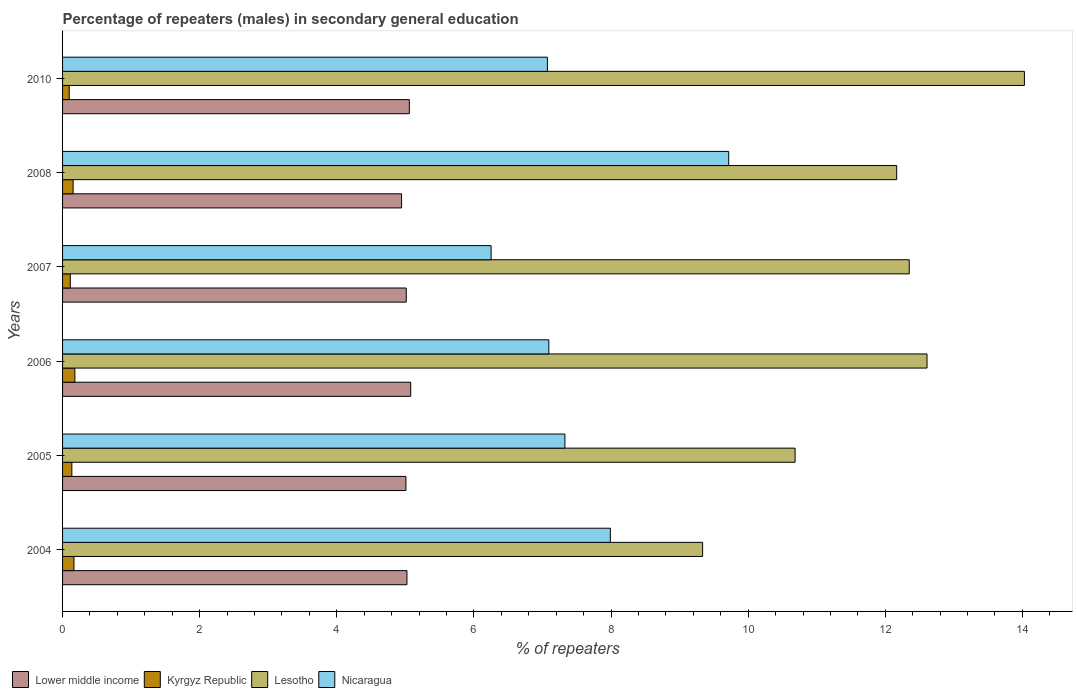How many different coloured bars are there?
Ensure brevity in your answer.  4. How many bars are there on the 2nd tick from the top?
Make the answer very short. 4. How many bars are there on the 3rd tick from the bottom?
Give a very brief answer. 4. What is the label of the 1st group of bars from the top?
Offer a very short reply. 2010. What is the percentage of male repeaters in Lesotho in 2005?
Keep it short and to the point. 10.68. Across all years, what is the maximum percentage of male repeaters in Lesotho?
Keep it short and to the point. 14.03. Across all years, what is the minimum percentage of male repeaters in Lower middle income?
Offer a very short reply. 4.94. What is the total percentage of male repeaters in Kyrgyz Republic in the graph?
Give a very brief answer. 0.84. What is the difference between the percentage of male repeaters in Nicaragua in 2006 and that in 2007?
Your answer should be compact. 0.84. What is the difference between the percentage of male repeaters in Lesotho in 2006 and the percentage of male repeaters in Lower middle income in 2008?
Provide a succinct answer. 7.66. What is the average percentage of male repeaters in Kyrgyz Republic per year?
Your answer should be very brief. 0.14. In the year 2007, what is the difference between the percentage of male repeaters in Kyrgyz Republic and percentage of male repeaters in Lower middle income?
Offer a terse response. -4.9. What is the ratio of the percentage of male repeaters in Lesotho in 2004 to that in 2005?
Offer a very short reply. 0.87. Is the difference between the percentage of male repeaters in Kyrgyz Republic in 2005 and 2008 greater than the difference between the percentage of male repeaters in Lower middle income in 2005 and 2008?
Give a very brief answer. No. What is the difference between the highest and the second highest percentage of male repeaters in Kyrgyz Republic?
Offer a terse response. 0.01. What is the difference between the highest and the lowest percentage of male repeaters in Lower middle income?
Your answer should be very brief. 0.13. What does the 2nd bar from the top in 2006 represents?
Make the answer very short. Lesotho. What does the 4th bar from the bottom in 2004 represents?
Give a very brief answer. Nicaragua. Is it the case that in every year, the sum of the percentage of male repeaters in Nicaragua and percentage of male repeaters in Kyrgyz Republic is greater than the percentage of male repeaters in Lesotho?
Your response must be concise. No. Are the values on the major ticks of X-axis written in scientific E-notation?
Offer a very short reply. No. Does the graph contain grids?
Offer a very short reply. No. Where does the legend appear in the graph?
Provide a succinct answer. Bottom left. How many legend labels are there?
Ensure brevity in your answer.  4. How are the legend labels stacked?
Provide a succinct answer. Horizontal. What is the title of the graph?
Make the answer very short. Percentage of repeaters (males) in secondary general education. Does "Tonga" appear as one of the legend labels in the graph?
Give a very brief answer. No. What is the label or title of the X-axis?
Provide a short and direct response. % of repeaters. What is the label or title of the Y-axis?
Offer a terse response. Years. What is the % of repeaters in Lower middle income in 2004?
Provide a short and direct response. 5.02. What is the % of repeaters in Kyrgyz Republic in 2004?
Give a very brief answer. 0.17. What is the % of repeaters of Lesotho in 2004?
Your answer should be very brief. 9.34. What is the % of repeaters of Nicaragua in 2004?
Make the answer very short. 7.99. What is the % of repeaters in Lower middle income in 2005?
Your answer should be very brief. 5.01. What is the % of repeaters of Kyrgyz Republic in 2005?
Your answer should be compact. 0.14. What is the % of repeaters of Lesotho in 2005?
Offer a very short reply. 10.68. What is the % of repeaters of Nicaragua in 2005?
Ensure brevity in your answer.  7.33. What is the % of repeaters in Lower middle income in 2006?
Provide a short and direct response. 5.08. What is the % of repeaters in Kyrgyz Republic in 2006?
Your response must be concise. 0.18. What is the % of repeaters in Lesotho in 2006?
Make the answer very short. 12.61. What is the % of repeaters of Nicaragua in 2006?
Provide a short and direct response. 7.09. What is the % of repeaters of Lower middle income in 2007?
Give a very brief answer. 5.01. What is the % of repeaters in Kyrgyz Republic in 2007?
Keep it short and to the point. 0.11. What is the % of repeaters in Lesotho in 2007?
Your answer should be very brief. 12.35. What is the % of repeaters of Nicaragua in 2007?
Give a very brief answer. 6.25. What is the % of repeaters of Lower middle income in 2008?
Give a very brief answer. 4.94. What is the % of repeaters in Kyrgyz Republic in 2008?
Your answer should be compact. 0.15. What is the % of repeaters of Lesotho in 2008?
Your answer should be compact. 12.17. What is the % of repeaters in Nicaragua in 2008?
Keep it short and to the point. 9.72. What is the % of repeaters in Lower middle income in 2010?
Give a very brief answer. 5.06. What is the % of repeaters of Kyrgyz Republic in 2010?
Your answer should be compact. 0.1. What is the % of repeaters of Lesotho in 2010?
Your answer should be compact. 14.03. What is the % of repeaters in Nicaragua in 2010?
Make the answer very short. 7.07. Across all years, what is the maximum % of repeaters in Lower middle income?
Ensure brevity in your answer.  5.08. Across all years, what is the maximum % of repeaters of Kyrgyz Republic?
Keep it short and to the point. 0.18. Across all years, what is the maximum % of repeaters in Lesotho?
Ensure brevity in your answer.  14.03. Across all years, what is the maximum % of repeaters in Nicaragua?
Ensure brevity in your answer.  9.72. Across all years, what is the minimum % of repeaters in Lower middle income?
Offer a terse response. 4.94. Across all years, what is the minimum % of repeaters of Kyrgyz Republic?
Your answer should be compact. 0.1. Across all years, what is the minimum % of repeaters of Lesotho?
Your response must be concise. 9.34. Across all years, what is the minimum % of repeaters in Nicaragua?
Provide a succinct answer. 6.25. What is the total % of repeaters in Lower middle income in the graph?
Ensure brevity in your answer.  30.13. What is the total % of repeaters of Kyrgyz Republic in the graph?
Give a very brief answer. 0.84. What is the total % of repeaters in Lesotho in the graph?
Give a very brief answer. 71.18. What is the total % of repeaters in Nicaragua in the graph?
Keep it short and to the point. 45.45. What is the difference between the % of repeaters of Lower middle income in 2004 and that in 2005?
Your answer should be compact. 0.01. What is the difference between the % of repeaters of Kyrgyz Republic in 2004 and that in 2005?
Your answer should be very brief. 0.03. What is the difference between the % of repeaters of Lesotho in 2004 and that in 2005?
Your response must be concise. -1.35. What is the difference between the % of repeaters of Nicaragua in 2004 and that in 2005?
Make the answer very short. 0.66. What is the difference between the % of repeaters in Lower middle income in 2004 and that in 2006?
Offer a terse response. -0.05. What is the difference between the % of repeaters in Kyrgyz Republic in 2004 and that in 2006?
Provide a short and direct response. -0.01. What is the difference between the % of repeaters in Lesotho in 2004 and that in 2006?
Provide a succinct answer. -3.27. What is the difference between the % of repeaters of Nicaragua in 2004 and that in 2006?
Offer a very short reply. 0.9. What is the difference between the % of repeaters in Lower middle income in 2004 and that in 2007?
Provide a short and direct response. 0.01. What is the difference between the % of repeaters of Kyrgyz Republic in 2004 and that in 2007?
Make the answer very short. 0.05. What is the difference between the % of repeaters of Lesotho in 2004 and that in 2007?
Offer a terse response. -3.01. What is the difference between the % of repeaters of Nicaragua in 2004 and that in 2007?
Make the answer very short. 1.74. What is the difference between the % of repeaters of Lower middle income in 2004 and that in 2008?
Ensure brevity in your answer.  0.08. What is the difference between the % of repeaters in Kyrgyz Republic in 2004 and that in 2008?
Provide a short and direct response. 0.01. What is the difference between the % of repeaters of Lesotho in 2004 and that in 2008?
Provide a succinct answer. -2.83. What is the difference between the % of repeaters of Nicaragua in 2004 and that in 2008?
Ensure brevity in your answer.  -1.73. What is the difference between the % of repeaters of Lower middle income in 2004 and that in 2010?
Give a very brief answer. -0.03. What is the difference between the % of repeaters in Kyrgyz Republic in 2004 and that in 2010?
Ensure brevity in your answer.  0.07. What is the difference between the % of repeaters of Lesotho in 2004 and that in 2010?
Your answer should be very brief. -4.69. What is the difference between the % of repeaters of Nicaragua in 2004 and that in 2010?
Give a very brief answer. 0.92. What is the difference between the % of repeaters in Lower middle income in 2005 and that in 2006?
Provide a succinct answer. -0.07. What is the difference between the % of repeaters in Kyrgyz Republic in 2005 and that in 2006?
Give a very brief answer. -0.04. What is the difference between the % of repeaters of Lesotho in 2005 and that in 2006?
Make the answer very short. -1.92. What is the difference between the % of repeaters of Nicaragua in 2005 and that in 2006?
Provide a succinct answer. 0.23. What is the difference between the % of repeaters of Lower middle income in 2005 and that in 2007?
Offer a terse response. -0. What is the difference between the % of repeaters in Kyrgyz Republic in 2005 and that in 2007?
Make the answer very short. 0.02. What is the difference between the % of repeaters in Lesotho in 2005 and that in 2007?
Offer a terse response. -1.66. What is the difference between the % of repeaters of Nicaragua in 2005 and that in 2007?
Make the answer very short. 1.08. What is the difference between the % of repeaters of Lower middle income in 2005 and that in 2008?
Your answer should be very brief. 0.06. What is the difference between the % of repeaters in Kyrgyz Republic in 2005 and that in 2008?
Give a very brief answer. -0.02. What is the difference between the % of repeaters of Lesotho in 2005 and that in 2008?
Make the answer very short. -1.48. What is the difference between the % of repeaters in Nicaragua in 2005 and that in 2008?
Provide a succinct answer. -2.39. What is the difference between the % of repeaters of Lower middle income in 2005 and that in 2010?
Your answer should be compact. -0.05. What is the difference between the % of repeaters in Kyrgyz Republic in 2005 and that in 2010?
Provide a short and direct response. 0.04. What is the difference between the % of repeaters in Lesotho in 2005 and that in 2010?
Offer a terse response. -3.34. What is the difference between the % of repeaters of Nicaragua in 2005 and that in 2010?
Make the answer very short. 0.26. What is the difference between the % of repeaters of Lower middle income in 2006 and that in 2007?
Provide a succinct answer. 0.06. What is the difference between the % of repeaters of Kyrgyz Republic in 2006 and that in 2007?
Keep it short and to the point. 0.07. What is the difference between the % of repeaters of Lesotho in 2006 and that in 2007?
Your answer should be very brief. 0.26. What is the difference between the % of repeaters in Nicaragua in 2006 and that in 2007?
Ensure brevity in your answer.  0.84. What is the difference between the % of repeaters of Lower middle income in 2006 and that in 2008?
Your answer should be very brief. 0.13. What is the difference between the % of repeaters in Kyrgyz Republic in 2006 and that in 2008?
Provide a short and direct response. 0.03. What is the difference between the % of repeaters in Lesotho in 2006 and that in 2008?
Offer a very short reply. 0.44. What is the difference between the % of repeaters of Nicaragua in 2006 and that in 2008?
Your answer should be compact. -2.62. What is the difference between the % of repeaters in Lower middle income in 2006 and that in 2010?
Ensure brevity in your answer.  0.02. What is the difference between the % of repeaters of Kyrgyz Republic in 2006 and that in 2010?
Provide a succinct answer. 0.08. What is the difference between the % of repeaters of Lesotho in 2006 and that in 2010?
Give a very brief answer. -1.42. What is the difference between the % of repeaters in Nicaragua in 2006 and that in 2010?
Ensure brevity in your answer.  0.02. What is the difference between the % of repeaters in Lower middle income in 2007 and that in 2008?
Offer a very short reply. 0.07. What is the difference between the % of repeaters of Kyrgyz Republic in 2007 and that in 2008?
Your answer should be compact. -0.04. What is the difference between the % of repeaters in Lesotho in 2007 and that in 2008?
Keep it short and to the point. 0.18. What is the difference between the % of repeaters in Nicaragua in 2007 and that in 2008?
Provide a short and direct response. -3.47. What is the difference between the % of repeaters of Lower middle income in 2007 and that in 2010?
Ensure brevity in your answer.  -0.04. What is the difference between the % of repeaters of Kyrgyz Republic in 2007 and that in 2010?
Provide a succinct answer. 0.02. What is the difference between the % of repeaters of Lesotho in 2007 and that in 2010?
Your answer should be very brief. -1.68. What is the difference between the % of repeaters in Nicaragua in 2007 and that in 2010?
Offer a very short reply. -0.82. What is the difference between the % of repeaters of Lower middle income in 2008 and that in 2010?
Your answer should be very brief. -0.11. What is the difference between the % of repeaters in Kyrgyz Republic in 2008 and that in 2010?
Give a very brief answer. 0.06. What is the difference between the % of repeaters in Lesotho in 2008 and that in 2010?
Provide a succinct answer. -1.86. What is the difference between the % of repeaters in Nicaragua in 2008 and that in 2010?
Keep it short and to the point. 2.64. What is the difference between the % of repeaters of Lower middle income in 2004 and the % of repeaters of Kyrgyz Republic in 2005?
Give a very brief answer. 4.89. What is the difference between the % of repeaters of Lower middle income in 2004 and the % of repeaters of Lesotho in 2005?
Your answer should be very brief. -5.66. What is the difference between the % of repeaters of Lower middle income in 2004 and the % of repeaters of Nicaragua in 2005?
Offer a terse response. -2.3. What is the difference between the % of repeaters in Kyrgyz Republic in 2004 and the % of repeaters in Lesotho in 2005?
Your answer should be compact. -10.52. What is the difference between the % of repeaters of Kyrgyz Republic in 2004 and the % of repeaters of Nicaragua in 2005?
Your answer should be compact. -7.16. What is the difference between the % of repeaters of Lesotho in 2004 and the % of repeaters of Nicaragua in 2005?
Give a very brief answer. 2.01. What is the difference between the % of repeaters in Lower middle income in 2004 and the % of repeaters in Kyrgyz Republic in 2006?
Keep it short and to the point. 4.84. What is the difference between the % of repeaters in Lower middle income in 2004 and the % of repeaters in Lesotho in 2006?
Provide a succinct answer. -7.59. What is the difference between the % of repeaters in Lower middle income in 2004 and the % of repeaters in Nicaragua in 2006?
Provide a short and direct response. -2.07. What is the difference between the % of repeaters of Kyrgyz Republic in 2004 and the % of repeaters of Lesotho in 2006?
Ensure brevity in your answer.  -12.44. What is the difference between the % of repeaters of Kyrgyz Republic in 2004 and the % of repeaters of Nicaragua in 2006?
Keep it short and to the point. -6.93. What is the difference between the % of repeaters in Lesotho in 2004 and the % of repeaters in Nicaragua in 2006?
Offer a terse response. 2.24. What is the difference between the % of repeaters in Lower middle income in 2004 and the % of repeaters in Kyrgyz Republic in 2007?
Your response must be concise. 4.91. What is the difference between the % of repeaters of Lower middle income in 2004 and the % of repeaters of Lesotho in 2007?
Make the answer very short. -7.33. What is the difference between the % of repeaters in Lower middle income in 2004 and the % of repeaters in Nicaragua in 2007?
Your answer should be compact. -1.23. What is the difference between the % of repeaters of Kyrgyz Republic in 2004 and the % of repeaters of Lesotho in 2007?
Keep it short and to the point. -12.18. What is the difference between the % of repeaters of Kyrgyz Republic in 2004 and the % of repeaters of Nicaragua in 2007?
Ensure brevity in your answer.  -6.08. What is the difference between the % of repeaters of Lesotho in 2004 and the % of repeaters of Nicaragua in 2007?
Give a very brief answer. 3.08. What is the difference between the % of repeaters in Lower middle income in 2004 and the % of repeaters in Kyrgyz Republic in 2008?
Your response must be concise. 4.87. What is the difference between the % of repeaters of Lower middle income in 2004 and the % of repeaters of Lesotho in 2008?
Your answer should be very brief. -7.14. What is the difference between the % of repeaters in Lower middle income in 2004 and the % of repeaters in Nicaragua in 2008?
Offer a terse response. -4.69. What is the difference between the % of repeaters of Kyrgyz Republic in 2004 and the % of repeaters of Lesotho in 2008?
Your answer should be very brief. -12. What is the difference between the % of repeaters of Kyrgyz Republic in 2004 and the % of repeaters of Nicaragua in 2008?
Your answer should be very brief. -9.55. What is the difference between the % of repeaters in Lesotho in 2004 and the % of repeaters in Nicaragua in 2008?
Your answer should be compact. -0.38. What is the difference between the % of repeaters in Lower middle income in 2004 and the % of repeaters in Kyrgyz Republic in 2010?
Your response must be concise. 4.93. What is the difference between the % of repeaters of Lower middle income in 2004 and the % of repeaters of Lesotho in 2010?
Give a very brief answer. -9.01. What is the difference between the % of repeaters in Lower middle income in 2004 and the % of repeaters in Nicaragua in 2010?
Your answer should be very brief. -2.05. What is the difference between the % of repeaters in Kyrgyz Republic in 2004 and the % of repeaters in Lesotho in 2010?
Provide a short and direct response. -13.86. What is the difference between the % of repeaters in Kyrgyz Republic in 2004 and the % of repeaters in Nicaragua in 2010?
Make the answer very short. -6.91. What is the difference between the % of repeaters of Lesotho in 2004 and the % of repeaters of Nicaragua in 2010?
Your answer should be very brief. 2.26. What is the difference between the % of repeaters in Lower middle income in 2005 and the % of repeaters in Kyrgyz Republic in 2006?
Provide a short and direct response. 4.83. What is the difference between the % of repeaters in Lower middle income in 2005 and the % of repeaters in Lesotho in 2006?
Your answer should be compact. -7.6. What is the difference between the % of repeaters of Lower middle income in 2005 and the % of repeaters of Nicaragua in 2006?
Provide a short and direct response. -2.08. What is the difference between the % of repeaters in Kyrgyz Republic in 2005 and the % of repeaters in Lesotho in 2006?
Make the answer very short. -12.47. What is the difference between the % of repeaters in Kyrgyz Republic in 2005 and the % of repeaters in Nicaragua in 2006?
Make the answer very short. -6.96. What is the difference between the % of repeaters in Lesotho in 2005 and the % of repeaters in Nicaragua in 2006?
Offer a very short reply. 3.59. What is the difference between the % of repeaters in Lower middle income in 2005 and the % of repeaters in Kyrgyz Republic in 2007?
Your answer should be compact. 4.9. What is the difference between the % of repeaters in Lower middle income in 2005 and the % of repeaters in Lesotho in 2007?
Your answer should be compact. -7.34. What is the difference between the % of repeaters of Lower middle income in 2005 and the % of repeaters of Nicaragua in 2007?
Your answer should be very brief. -1.24. What is the difference between the % of repeaters in Kyrgyz Republic in 2005 and the % of repeaters in Lesotho in 2007?
Offer a terse response. -12.21. What is the difference between the % of repeaters of Kyrgyz Republic in 2005 and the % of repeaters of Nicaragua in 2007?
Provide a short and direct response. -6.12. What is the difference between the % of repeaters in Lesotho in 2005 and the % of repeaters in Nicaragua in 2007?
Offer a terse response. 4.43. What is the difference between the % of repeaters in Lower middle income in 2005 and the % of repeaters in Kyrgyz Republic in 2008?
Offer a terse response. 4.85. What is the difference between the % of repeaters in Lower middle income in 2005 and the % of repeaters in Lesotho in 2008?
Offer a terse response. -7.16. What is the difference between the % of repeaters in Lower middle income in 2005 and the % of repeaters in Nicaragua in 2008?
Your answer should be compact. -4.71. What is the difference between the % of repeaters of Kyrgyz Republic in 2005 and the % of repeaters of Lesotho in 2008?
Offer a terse response. -12.03. What is the difference between the % of repeaters of Kyrgyz Republic in 2005 and the % of repeaters of Nicaragua in 2008?
Offer a very short reply. -9.58. What is the difference between the % of repeaters of Lesotho in 2005 and the % of repeaters of Nicaragua in 2008?
Your answer should be very brief. 0.97. What is the difference between the % of repeaters in Lower middle income in 2005 and the % of repeaters in Kyrgyz Republic in 2010?
Provide a short and direct response. 4.91. What is the difference between the % of repeaters in Lower middle income in 2005 and the % of repeaters in Lesotho in 2010?
Your answer should be very brief. -9.02. What is the difference between the % of repeaters in Lower middle income in 2005 and the % of repeaters in Nicaragua in 2010?
Provide a succinct answer. -2.06. What is the difference between the % of repeaters of Kyrgyz Republic in 2005 and the % of repeaters of Lesotho in 2010?
Your answer should be compact. -13.89. What is the difference between the % of repeaters of Kyrgyz Republic in 2005 and the % of repeaters of Nicaragua in 2010?
Your answer should be very brief. -6.94. What is the difference between the % of repeaters of Lesotho in 2005 and the % of repeaters of Nicaragua in 2010?
Give a very brief answer. 3.61. What is the difference between the % of repeaters in Lower middle income in 2006 and the % of repeaters in Kyrgyz Republic in 2007?
Provide a succinct answer. 4.97. What is the difference between the % of repeaters of Lower middle income in 2006 and the % of repeaters of Lesotho in 2007?
Provide a succinct answer. -7.27. What is the difference between the % of repeaters in Lower middle income in 2006 and the % of repeaters in Nicaragua in 2007?
Provide a succinct answer. -1.17. What is the difference between the % of repeaters in Kyrgyz Republic in 2006 and the % of repeaters in Lesotho in 2007?
Keep it short and to the point. -12.17. What is the difference between the % of repeaters in Kyrgyz Republic in 2006 and the % of repeaters in Nicaragua in 2007?
Make the answer very short. -6.07. What is the difference between the % of repeaters in Lesotho in 2006 and the % of repeaters in Nicaragua in 2007?
Offer a very short reply. 6.36. What is the difference between the % of repeaters of Lower middle income in 2006 and the % of repeaters of Kyrgyz Republic in 2008?
Give a very brief answer. 4.92. What is the difference between the % of repeaters of Lower middle income in 2006 and the % of repeaters of Lesotho in 2008?
Your response must be concise. -7.09. What is the difference between the % of repeaters in Lower middle income in 2006 and the % of repeaters in Nicaragua in 2008?
Keep it short and to the point. -4.64. What is the difference between the % of repeaters of Kyrgyz Republic in 2006 and the % of repeaters of Lesotho in 2008?
Your answer should be compact. -11.99. What is the difference between the % of repeaters of Kyrgyz Republic in 2006 and the % of repeaters of Nicaragua in 2008?
Your answer should be very brief. -9.54. What is the difference between the % of repeaters of Lesotho in 2006 and the % of repeaters of Nicaragua in 2008?
Give a very brief answer. 2.89. What is the difference between the % of repeaters in Lower middle income in 2006 and the % of repeaters in Kyrgyz Republic in 2010?
Ensure brevity in your answer.  4.98. What is the difference between the % of repeaters of Lower middle income in 2006 and the % of repeaters of Lesotho in 2010?
Offer a terse response. -8.95. What is the difference between the % of repeaters of Lower middle income in 2006 and the % of repeaters of Nicaragua in 2010?
Offer a very short reply. -1.99. What is the difference between the % of repeaters of Kyrgyz Republic in 2006 and the % of repeaters of Lesotho in 2010?
Offer a very short reply. -13.85. What is the difference between the % of repeaters in Kyrgyz Republic in 2006 and the % of repeaters in Nicaragua in 2010?
Provide a short and direct response. -6.89. What is the difference between the % of repeaters of Lesotho in 2006 and the % of repeaters of Nicaragua in 2010?
Offer a terse response. 5.54. What is the difference between the % of repeaters in Lower middle income in 2007 and the % of repeaters in Kyrgyz Republic in 2008?
Your answer should be compact. 4.86. What is the difference between the % of repeaters of Lower middle income in 2007 and the % of repeaters of Lesotho in 2008?
Ensure brevity in your answer.  -7.15. What is the difference between the % of repeaters in Lower middle income in 2007 and the % of repeaters in Nicaragua in 2008?
Your answer should be very brief. -4.7. What is the difference between the % of repeaters in Kyrgyz Republic in 2007 and the % of repeaters in Lesotho in 2008?
Your answer should be compact. -12.05. What is the difference between the % of repeaters in Kyrgyz Republic in 2007 and the % of repeaters in Nicaragua in 2008?
Make the answer very short. -9.6. What is the difference between the % of repeaters of Lesotho in 2007 and the % of repeaters of Nicaragua in 2008?
Keep it short and to the point. 2.63. What is the difference between the % of repeaters in Lower middle income in 2007 and the % of repeaters in Kyrgyz Republic in 2010?
Offer a terse response. 4.92. What is the difference between the % of repeaters in Lower middle income in 2007 and the % of repeaters in Lesotho in 2010?
Offer a terse response. -9.02. What is the difference between the % of repeaters in Lower middle income in 2007 and the % of repeaters in Nicaragua in 2010?
Keep it short and to the point. -2.06. What is the difference between the % of repeaters in Kyrgyz Republic in 2007 and the % of repeaters in Lesotho in 2010?
Provide a succinct answer. -13.92. What is the difference between the % of repeaters of Kyrgyz Republic in 2007 and the % of repeaters of Nicaragua in 2010?
Ensure brevity in your answer.  -6.96. What is the difference between the % of repeaters of Lesotho in 2007 and the % of repeaters of Nicaragua in 2010?
Provide a succinct answer. 5.28. What is the difference between the % of repeaters in Lower middle income in 2008 and the % of repeaters in Kyrgyz Republic in 2010?
Offer a terse response. 4.85. What is the difference between the % of repeaters in Lower middle income in 2008 and the % of repeaters in Lesotho in 2010?
Your answer should be very brief. -9.08. What is the difference between the % of repeaters in Lower middle income in 2008 and the % of repeaters in Nicaragua in 2010?
Your answer should be very brief. -2.13. What is the difference between the % of repeaters in Kyrgyz Republic in 2008 and the % of repeaters in Lesotho in 2010?
Your answer should be very brief. -13.88. What is the difference between the % of repeaters in Kyrgyz Republic in 2008 and the % of repeaters in Nicaragua in 2010?
Give a very brief answer. -6.92. What is the difference between the % of repeaters in Lesotho in 2008 and the % of repeaters in Nicaragua in 2010?
Provide a succinct answer. 5.09. What is the average % of repeaters of Lower middle income per year?
Ensure brevity in your answer.  5.02. What is the average % of repeaters in Kyrgyz Republic per year?
Offer a terse response. 0.14. What is the average % of repeaters in Lesotho per year?
Your answer should be compact. 11.86. What is the average % of repeaters in Nicaragua per year?
Offer a terse response. 7.57. In the year 2004, what is the difference between the % of repeaters of Lower middle income and % of repeaters of Kyrgyz Republic?
Make the answer very short. 4.86. In the year 2004, what is the difference between the % of repeaters of Lower middle income and % of repeaters of Lesotho?
Ensure brevity in your answer.  -4.31. In the year 2004, what is the difference between the % of repeaters of Lower middle income and % of repeaters of Nicaragua?
Provide a short and direct response. -2.97. In the year 2004, what is the difference between the % of repeaters in Kyrgyz Republic and % of repeaters in Lesotho?
Offer a very short reply. -9.17. In the year 2004, what is the difference between the % of repeaters of Kyrgyz Republic and % of repeaters of Nicaragua?
Ensure brevity in your answer.  -7.82. In the year 2004, what is the difference between the % of repeaters of Lesotho and % of repeaters of Nicaragua?
Offer a very short reply. 1.35. In the year 2005, what is the difference between the % of repeaters in Lower middle income and % of repeaters in Kyrgyz Republic?
Provide a succinct answer. 4.87. In the year 2005, what is the difference between the % of repeaters of Lower middle income and % of repeaters of Lesotho?
Ensure brevity in your answer.  -5.68. In the year 2005, what is the difference between the % of repeaters of Lower middle income and % of repeaters of Nicaragua?
Provide a succinct answer. -2.32. In the year 2005, what is the difference between the % of repeaters of Kyrgyz Republic and % of repeaters of Lesotho?
Keep it short and to the point. -10.55. In the year 2005, what is the difference between the % of repeaters of Kyrgyz Republic and % of repeaters of Nicaragua?
Your answer should be very brief. -7.19. In the year 2005, what is the difference between the % of repeaters of Lesotho and % of repeaters of Nicaragua?
Your response must be concise. 3.36. In the year 2006, what is the difference between the % of repeaters of Lower middle income and % of repeaters of Kyrgyz Republic?
Offer a terse response. 4.9. In the year 2006, what is the difference between the % of repeaters of Lower middle income and % of repeaters of Lesotho?
Provide a succinct answer. -7.53. In the year 2006, what is the difference between the % of repeaters in Lower middle income and % of repeaters in Nicaragua?
Your answer should be compact. -2.01. In the year 2006, what is the difference between the % of repeaters in Kyrgyz Republic and % of repeaters in Lesotho?
Your answer should be compact. -12.43. In the year 2006, what is the difference between the % of repeaters in Kyrgyz Republic and % of repeaters in Nicaragua?
Ensure brevity in your answer.  -6.91. In the year 2006, what is the difference between the % of repeaters of Lesotho and % of repeaters of Nicaragua?
Offer a terse response. 5.52. In the year 2007, what is the difference between the % of repeaters of Lower middle income and % of repeaters of Kyrgyz Republic?
Keep it short and to the point. 4.9. In the year 2007, what is the difference between the % of repeaters in Lower middle income and % of repeaters in Lesotho?
Ensure brevity in your answer.  -7.34. In the year 2007, what is the difference between the % of repeaters in Lower middle income and % of repeaters in Nicaragua?
Your response must be concise. -1.24. In the year 2007, what is the difference between the % of repeaters in Kyrgyz Republic and % of repeaters in Lesotho?
Provide a short and direct response. -12.24. In the year 2007, what is the difference between the % of repeaters of Kyrgyz Republic and % of repeaters of Nicaragua?
Offer a very short reply. -6.14. In the year 2007, what is the difference between the % of repeaters of Lesotho and % of repeaters of Nicaragua?
Offer a terse response. 6.1. In the year 2008, what is the difference between the % of repeaters of Lower middle income and % of repeaters of Kyrgyz Republic?
Your answer should be compact. 4.79. In the year 2008, what is the difference between the % of repeaters of Lower middle income and % of repeaters of Lesotho?
Your answer should be compact. -7.22. In the year 2008, what is the difference between the % of repeaters of Lower middle income and % of repeaters of Nicaragua?
Provide a short and direct response. -4.77. In the year 2008, what is the difference between the % of repeaters of Kyrgyz Republic and % of repeaters of Lesotho?
Provide a succinct answer. -12.01. In the year 2008, what is the difference between the % of repeaters in Kyrgyz Republic and % of repeaters in Nicaragua?
Provide a succinct answer. -9.56. In the year 2008, what is the difference between the % of repeaters of Lesotho and % of repeaters of Nicaragua?
Your response must be concise. 2.45. In the year 2010, what is the difference between the % of repeaters of Lower middle income and % of repeaters of Kyrgyz Republic?
Keep it short and to the point. 4.96. In the year 2010, what is the difference between the % of repeaters in Lower middle income and % of repeaters in Lesotho?
Offer a very short reply. -8.97. In the year 2010, what is the difference between the % of repeaters in Lower middle income and % of repeaters in Nicaragua?
Provide a short and direct response. -2.01. In the year 2010, what is the difference between the % of repeaters of Kyrgyz Republic and % of repeaters of Lesotho?
Keep it short and to the point. -13.93. In the year 2010, what is the difference between the % of repeaters of Kyrgyz Republic and % of repeaters of Nicaragua?
Provide a short and direct response. -6.97. In the year 2010, what is the difference between the % of repeaters of Lesotho and % of repeaters of Nicaragua?
Offer a very short reply. 6.96. What is the ratio of the % of repeaters in Kyrgyz Republic in 2004 to that in 2005?
Make the answer very short. 1.23. What is the ratio of the % of repeaters of Lesotho in 2004 to that in 2005?
Provide a succinct answer. 0.87. What is the ratio of the % of repeaters of Nicaragua in 2004 to that in 2005?
Make the answer very short. 1.09. What is the ratio of the % of repeaters in Kyrgyz Republic in 2004 to that in 2006?
Make the answer very short. 0.92. What is the ratio of the % of repeaters of Lesotho in 2004 to that in 2006?
Your answer should be compact. 0.74. What is the ratio of the % of repeaters of Nicaragua in 2004 to that in 2006?
Your answer should be compact. 1.13. What is the ratio of the % of repeaters in Kyrgyz Republic in 2004 to that in 2007?
Offer a very short reply. 1.47. What is the ratio of the % of repeaters of Lesotho in 2004 to that in 2007?
Offer a terse response. 0.76. What is the ratio of the % of repeaters of Nicaragua in 2004 to that in 2007?
Provide a succinct answer. 1.28. What is the ratio of the % of repeaters of Lower middle income in 2004 to that in 2008?
Provide a short and direct response. 1.02. What is the ratio of the % of repeaters in Kyrgyz Republic in 2004 to that in 2008?
Provide a short and direct response. 1.08. What is the ratio of the % of repeaters in Lesotho in 2004 to that in 2008?
Ensure brevity in your answer.  0.77. What is the ratio of the % of repeaters in Nicaragua in 2004 to that in 2008?
Your answer should be compact. 0.82. What is the ratio of the % of repeaters of Lower middle income in 2004 to that in 2010?
Offer a very short reply. 0.99. What is the ratio of the % of repeaters of Kyrgyz Republic in 2004 to that in 2010?
Offer a terse response. 1.71. What is the ratio of the % of repeaters of Lesotho in 2004 to that in 2010?
Your response must be concise. 0.67. What is the ratio of the % of repeaters in Nicaragua in 2004 to that in 2010?
Your response must be concise. 1.13. What is the ratio of the % of repeaters of Lower middle income in 2005 to that in 2006?
Your response must be concise. 0.99. What is the ratio of the % of repeaters of Kyrgyz Republic in 2005 to that in 2006?
Your answer should be very brief. 0.75. What is the ratio of the % of repeaters in Lesotho in 2005 to that in 2006?
Ensure brevity in your answer.  0.85. What is the ratio of the % of repeaters of Nicaragua in 2005 to that in 2006?
Your answer should be very brief. 1.03. What is the ratio of the % of repeaters of Lower middle income in 2005 to that in 2007?
Offer a terse response. 1. What is the ratio of the % of repeaters in Kyrgyz Republic in 2005 to that in 2007?
Make the answer very short. 1.2. What is the ratio of the % of repeaters of Lesotho in 2005 to that in 2007?
Give a very brief answer. 0.87. What is the ratio of the % of repeaters in Nicaragua in 2005 to that in 2007?
Keep it short and to the point. 1.17. What is the ratio of the % of repeaters in Lower middle income in 2005 to that in 2008?
Provide a succinct answer. 1.01. What is the ratio of the % of repeaters in Kyrgyz Republic in 2005 to that in 2008?
Give a very brief answer. 0.88. What is the ratio of the % of repeaters in Lesotho in 2005 to that in 2008?
Your response must be concise. 0.88. What is the ratio of the % of repeaters of Nicaragua in 2005 to that in 2008?
Give a very brief answer. 0.75. What is the ratio of the % of repeaters in Lower middle income in 2005 to that in 2010?
Provide a short and direct response. 0.99. What is the ratio of the % of repeaters in Kyrgyz Republic in 2005 to that in 2010?
Give a very brief answer. 1.39. What is the ratio of the % of repeaters in Lesotho in 2005 to that in 2010?
Provide a succinct answer. 0.76. What is the ratio of the % of repeaters of Nicaragua in 2005 to that in 2010?
Provide a succinct answer. 1.04. What is the ratio of the % of repeaters of Lower middle income in 2006 to that in 2007?
Ensure brevity in your answer.  1.01. What is the ratio of the % of repeaters of Kyrgyz Republic in 2006 to that in 2007?
Your answer should be compact. 1.59. What is the ratio of the % of repeaters in Nicaragua in 2006 to that in 2007?
Offer a terse response. 1.13. What is the ratio of the % of repeaters of Lower middle income in 2006 to that in 2008?
Give a very brief answer. 1.03. What is the ratio of the % of repeaters of Kyrgyz Republic in 2006 to that in 2008?
Make the answer very short. 1.17. What is the ratio of the % of repeaters of Lesotho in 2006 to that in 2008?
Ensure brevity in your answer.  1.04. What is the ratio of the % of repeaters in Nicaragua in 2006 to that in 2008?
Provide a succinct answer. 0.73. What is the ratio of the % of repeaters of Kyrgyz Republic in 2006 to that in 2010?
Provide a short and direct response. 1.85. What is the ratio of the % of repeaters in Lesotho in 2006 to that in 2010?
Provide a short and direct response. 0.9. What is the ratio of the % of repeaters of Nicaragua in 2006 to that in 2010?
Make the answer very short. 1. What is the ratio of the % of repeaters in Lower middle income in 2007 to that in 2008?
Ensure brevity in your answer.  1.01. What is the ratio of the % of repeaters in Kyrgyz Republic in 2007 to that in 2008?
Provide a succinct answer. 0.73. What is the ratio of the % of repeaters in Lesotho in 2007 to that in 2008?
Provide a short and direct response. 1.02. What is the ratio of the % of repeaters of Nicaragua in 2007 to that in 2008?
Give a very brief answer. 0.64. What is the ratio of the % of repeaters in Kyrgyz Republic in 2007 to that in 2010?
Your answer should be compact. 1.16. What is the ratio of the % of repeaters of Lesotho in 2007 to that in 2010?
Keep it short and to the point. 0.88. What is the ratio of the % of repeaters in Nicaragua in 2007 to that in 2010?
Make the answer very short. 0.88. What is the ratio of the % of repeaters of Lower middle income in 2008 to that in 2010?
Offer a terse response. 0.98. What is the ratio of the % of repeaters of Kyrgyz Republic in 2008 to that in 2010?
Your answer should be very brief. 1.58. What is the ratio of the % of repeaters in Lesotho in 2008 to that in 2010?
Your answer should be very brief. 0.87. What is the ratio of the % of repeaters of Nicaragua in 2008 to that in 2010?
Offer a terse response. 1.37. What is the difference between the highest and the second highest % of repeaters in Lower middle income?
Your answer should be compact. 0.02. What is the difference between the highest and the second highest % of repeaters of Kyrgyz Republic?
Your answer should be very brief. 0.01. What is the difference between the highest and the second highest % of repeaters in Lesotho?
Your response must be concise. 1.42. What is the difference between the highest and the second highest % of repeaters of Nicaragua?
Your response must be concise. 1.73. What is the difference between the highest and the lowest % of repeaters in Lower middle income?
Your answer should be very brief. 0.13. What is the difference between the highest and the lowest % of repeaters in Kyrgyz Republic?
Your response must be concise. 0.08. What is the difference between the highest and the lowest % of repeaters in Lesotho?
Your response must be concise. 4.69. What is the difference between the highest and the lowest % of repeaters of Nicaragua?
Provide a succinct answer. 3.47. 